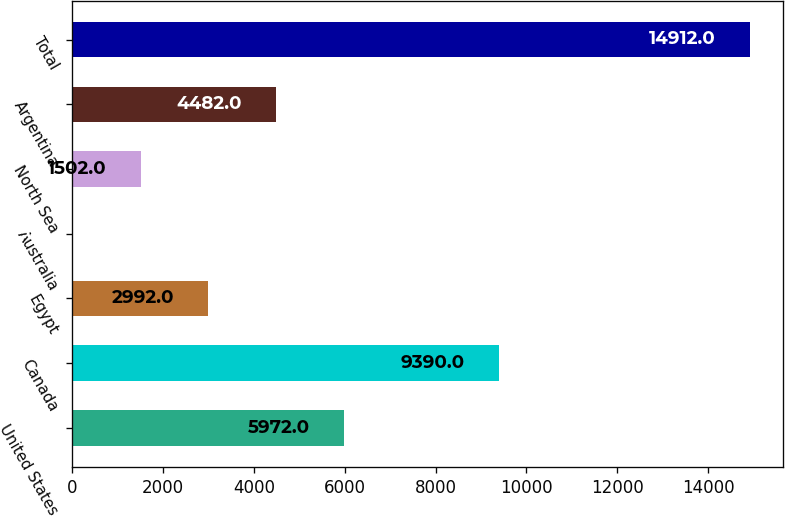Convert chart to OTSL. <chart><loc_0><loc_0><loc_500><loc_500><bar_chart><fcel>United States<fcel>Canada<fcel>Egypt<fcel>Australia<fcel>North Sea<fcel>Argentina<fcel>Total<nl><fcel>5972<fcel>9390<fcel>2992<fcel>12<fcel>1502<fcel>4482<fcel>14912<nl></chart> 